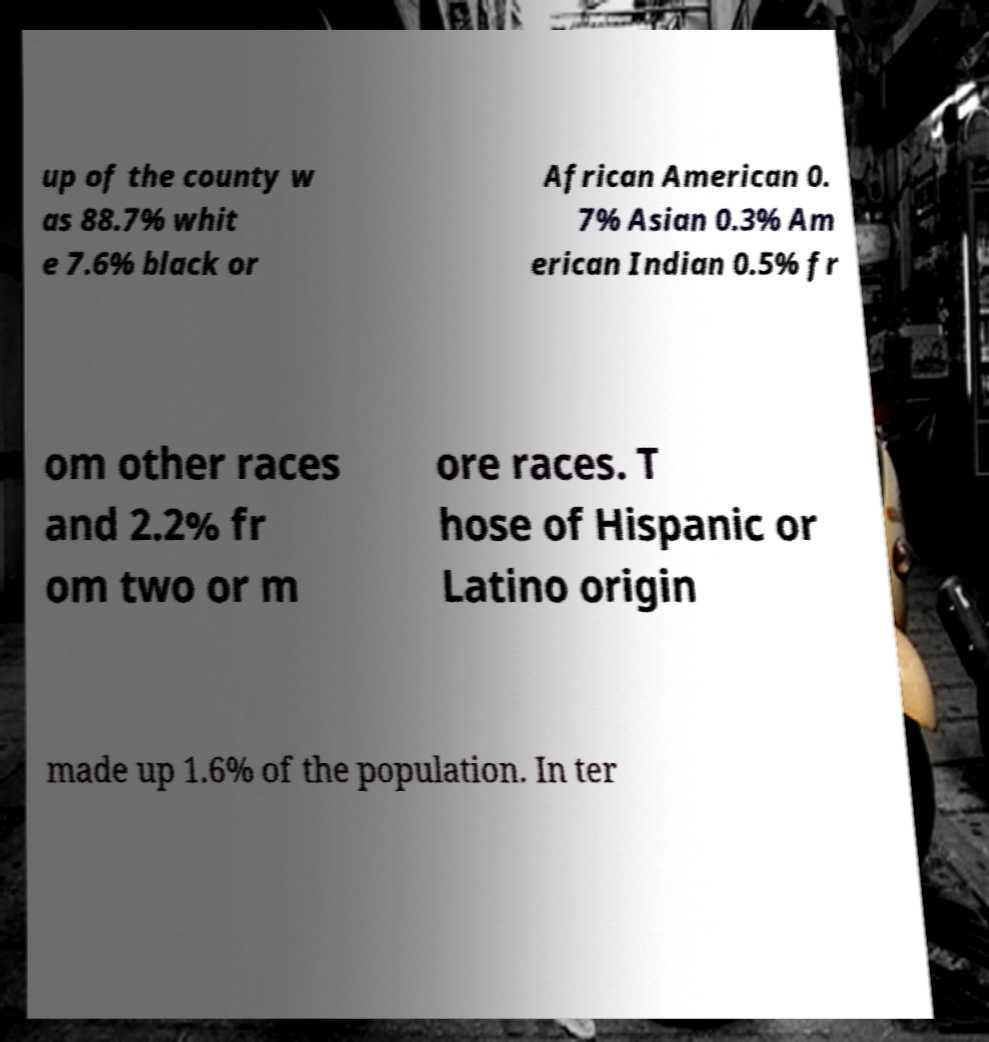Please read and relay the text visible in this image. What does it say? up of the county w as 88.7% whit e 7.6% black or African American 0. 7% Asian 0.3% Am erican Indian 0.5% fr om other races and 2.2% fr om two or m ore races. T hose of Hispanic or Latino origin made up 1.6% of the population. In ter 